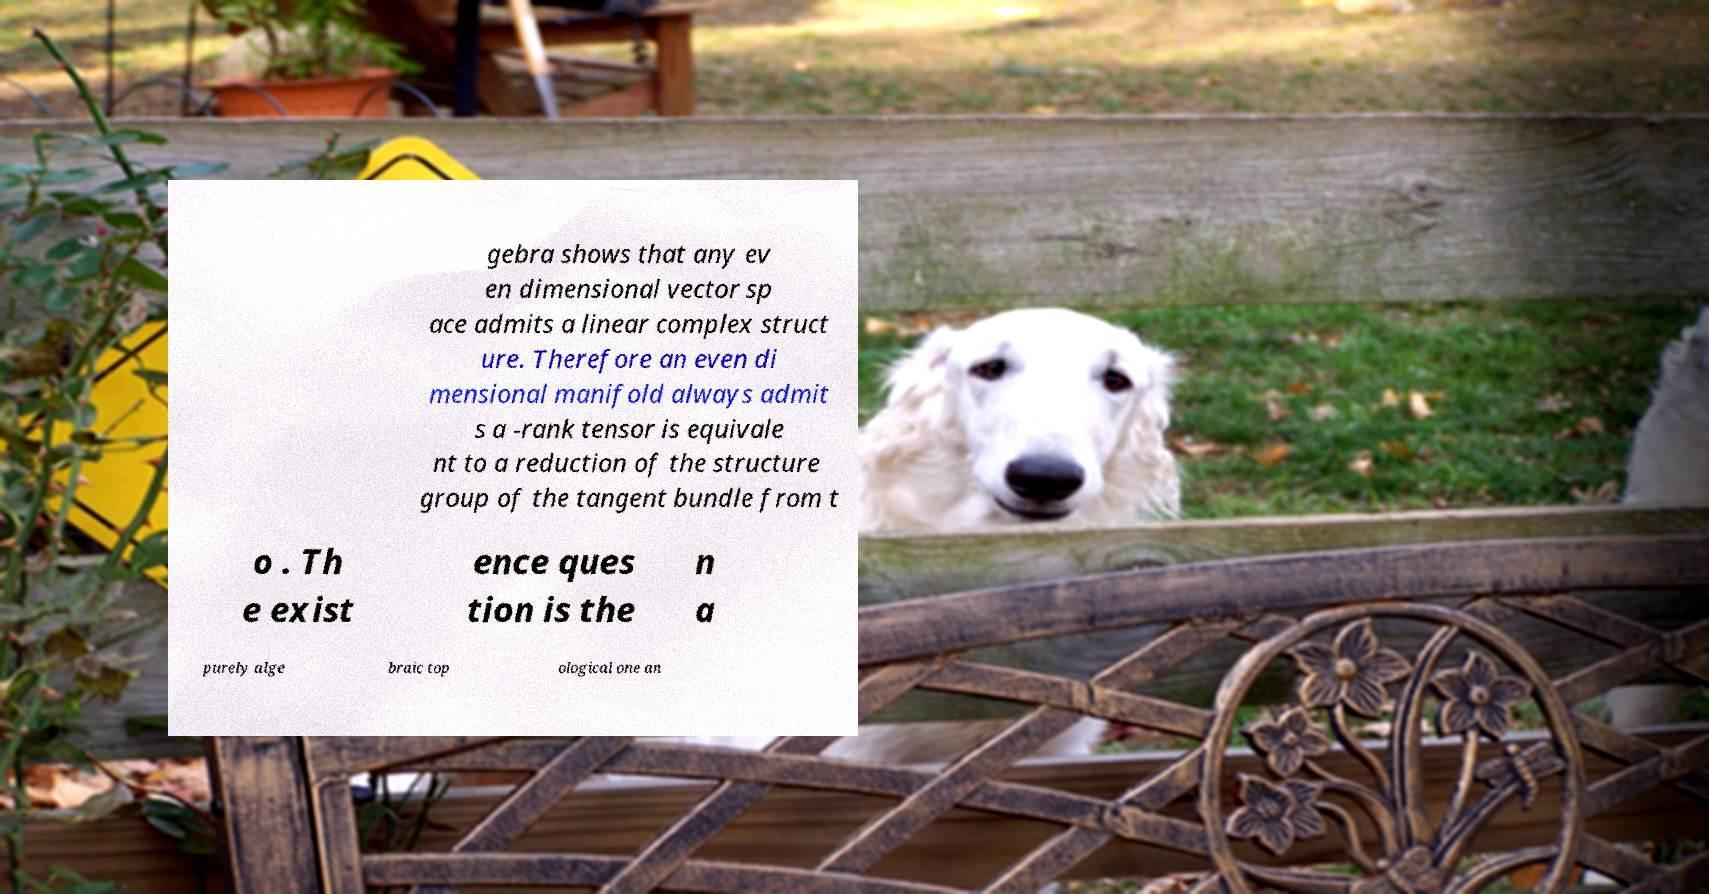Please read and relay the text visible in this image. What does it say? gebra shows that any ev en dimensional vector sp ace admits a linear complex struct ure. Therefore an even di mensional manifold always admit s a -rank tensor is equivale nt to a reduction of the structure group of the tangent bundle from t o . Th e exist ence ques tion is the n a purely alge braic top ological one an 